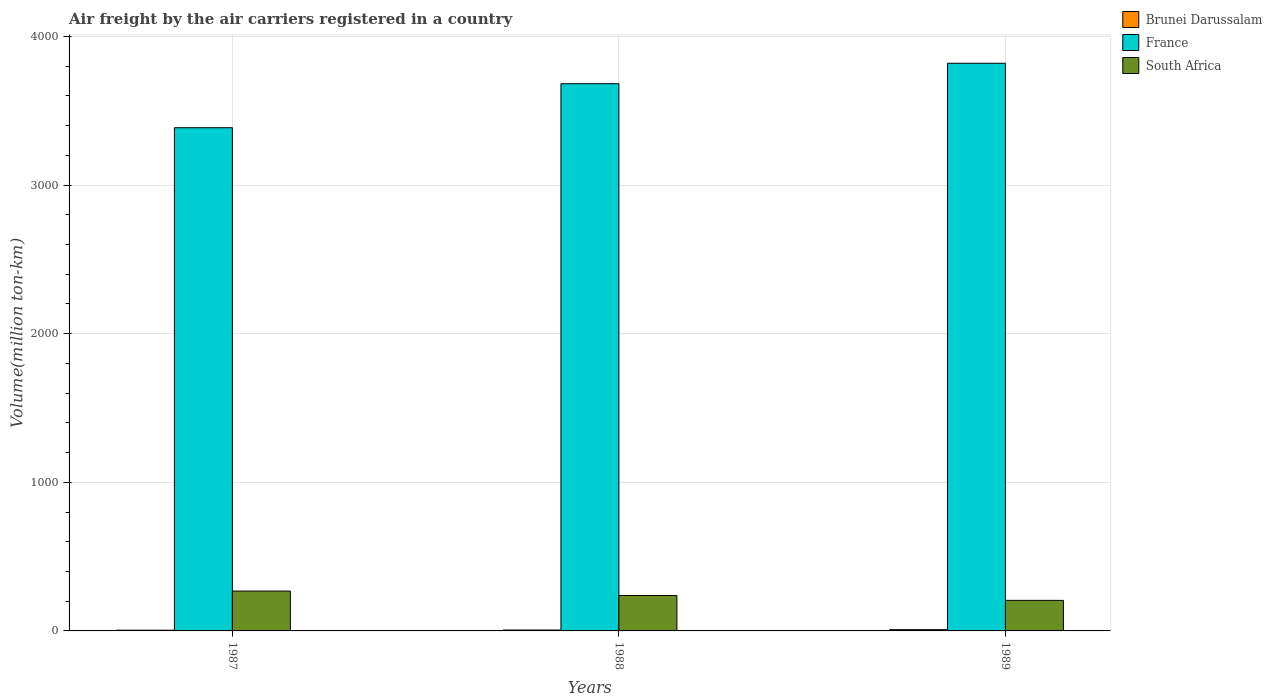How many different coloured bars are there?
Your answer should be compact. 3. Are the number of bars on each tick of the X-axis equal?
Give a very brief answer. Yes. How many bars are there on the 3rd tick from the right?
Offer a very short reply. 3. What is the label of the 2nd group of bars from the left?
Your answer should be very brief. 1988. In how many cases, is the number of bars for a given year not equal to the number of legend labels?
Make the answer very short. 0. What is the volume of the air carriers in Brunei Darussalam in 1988?
Keep it short and to the point. 6. Across all years, what is the maximum volume of the air carriers in France?
Offer a very short reply. 3819.3. Across all years, what is the minimum volume of the air carriers in France?
Offer a terse response. 3385.6. In which year was the volume of the air carriers in France maximum?
Offer a very short reply. 1989. In which year was the volume of the air carriers in France minimum?
Make the answer very short. 1987. What is the total volume of the air carriers in Brunei Darussalam in the graph?
Provide a short and direct response. 19.5. What is the difference between the volume of the air carriers in Brunei Darussalam in 1988 and that in 1989?
Provide a succinct answer. -2.6. What is the difference between the volume of the air carriers in France in 1988 and the volume of the air carriers in South Africa in 1989?
Ensure brevity in your answer.  3476. What is the average volume of the air carriers in France per year?
Provide a succinct answer. 3628.83. In the year 1987, what is the difference between the volume of the air carriers in France and volume of the air carriers in Brunei Darussalam?
Offer a very short reply. 3380.7. In how many years, is the volume of the air carriers in Brunei Darussalam greater than 1200 million ton-km?
Your answer should be compact. 0. What is the ratio of the volume of the air carriers in South Africa in 1987 to that in 1989?
Make the answer very short. 1.3. Is the difference between the volume of the air carriers in France in 1987 and 1988 greater than the difference between the volume of the air carriers in Brunei Darussalam in 1987 and 1988?
Make the answer very short. No. What is the difference between the highest and the second highest volume of the air carriers in Brunei Darussalam?
Provide a succinct answer. 2.6. What is the difference between the highest and the lowest volume of the air carriers in Brunei Darussalam?
Your answer should be very brief. 3.7. In how many years, is the volume of the air carriers in France greater than the average volume of the air carriers in France taken over all years?
Offer a very short reply. 2. What does the 1st bar from the left in 1989 represents?
Provide a short and direct response. Brunei Darussalam. What does the 2nd bar from the right in 1989 represents?
Provide a succinct answer. France. Is it the case that in every year, the sum of the volume of the air carriers in South Africa and volume of the air carriers in France is greater than the volume of the air carriers in Brunei Darussalam?
Your answer should be compact. Yes. What is the difference between two consecutive major ticks on the Y-axis?
Offer a terse response. 1000. Does the graph contain any zero values?
Ensure brevity in your answer.  No. Where does the legend appear in the graph?
Provide a short and direct response. Top right. What is the title of the graph?
Your answer should be very brief. Air freight by the air carriers registered in a country. What is the label or title of the Y-axis?
Your answer should be very brief. Volume(million ton-km). What is the Volume(million ton-km) in Brunei Darussalam in 1987?
Your response must be concise. 4.9. What is the Volume(million ton-km) in France in 1987?
Keep it short and to the point. 3385.6. What is the Volume(million ton-km) of South Africa in 1987?
Your answer should be very brief. 268.1. What is the Volume(million ton-km) of Brunei Darussalam in 1988?
Keep it short and to the point. 6. What is the Volume(million ton-km) in France in 1988?
Offer a terse response. 3681.6. What is the Volume(million ton-km) in South Africa in 1988?
Give a very brief answer. 238.3. What is the Volume(million ton-km) of Brunei Darussalam in 1989?
Provide a succinct answer. 8.6. What is the Volume(million ton-km) of France in 1989?
Offer a very short reply. 3819.3. What is the Volume(million ton-km) in South Africa in 1989?
Your answer should be compact. 205.6. Across all years, what is the maximum Volume(million ton-km) of Brunei Darussalam?
Your response must be concise. 8.6. Across all years, what is the maximum Volume(million ton-km) in France?
Give a very brief answer. 3819.3. Across all years, what is the maximum Volume(million ton-km) in South Africa?
Provide a short and direct response. 268.1. Across all years, what is the minimum Volume(million ton-km) of Brunei Darussalam?
Offer a terse response. 4.9. Across all years, what is the minimum Volume(million ton-km) of France?
Your answer should be very brief. 3385.6. Across all years, what is the minimum Volume(million ton-km) of South Africa?
Offer a terse response. 205.6. What is the total Volume(million ton-km) of France in the graph?
Provide a short and direct response. 1.09e+04. What is the total Volume(million ton-km) in South Africa in the graph?
Provide a short and direct response. 712. What is the difference between the Volume(million ton-km) of France in 1987 and that in 1988?
Your answer should be compact. -296. What is the difference between the Volume(million ton-km) of South Africa in 1987 and that in 1988?
Keep it short and to the point. 29.8. What is the difference between the Volume(million ton-km) in Brunei Darussalam in 1987 and that in 1989?
Your response must be concise. -3.7. What is the difference between the Volume(million ton-km) of France in 1987 and that in 1989?
Provide a short and direct response. -433.7. What is the difference between the Volume(million ton-km) of South Africa in 1987 and that in 1989?
Ensure brevity in your answer.  62.5. What is the difference between the Volume(million ton-km) in France in 1988 and that in 1989?
Offer a terse response. -137.7. What is the difference between the Volume(million ton-km) in South Africa in 1988 and that in 1989?
Keep it short and to the point. 32.7. What is the difference between the Volume(million ton-km) in Brunei Darussalam in 1987 and the Volume(million ton-km) in France in 1988?
Make the answer very short. -3676.7. What is the difference between the Volume(million ton-km) of Brunei Darussalam in 1987 and the Volume(million ton-km) of South Africa in 1988?
Provide a succinct answer. -233.4. What is the difference between the Volume(million ton-km) of France in 1987 and the Volume(million ton-km) of South Africa in 1988?
Offer a very short reply. 3147.3. What is the difference between the Volume(million ton-km) of Brunei Darussalam in 1987 and the Volume(million ton-km) of France in 1989?
Provide a short and direct response. -3814.4. What is the difference between the Volume(million ton-km) of Brunei Darussalam in 1987 and the Volume(million ton-km) of South Africa in 1989?
Offer a very short reply. -200.7. What is the difference between the Volume(million ton-km) in France in 1987 and the Volume(million ton-km) in South Africa in 1989?
Ensure brevity in your answer.  3180. What is the difference between the Volume(million ton-km) in Brunei Darussalam in 1988 and the Volume(million ton-km) in France in 1989?
Give a very brief answer. -3813.3. What is the difference between the Volume(million ton-km) of Brunei Darussalam in 1988 and the Volume(million ton-km) of South Africa in 1989?
Provide a succinct answer. -199.6. What is the difference between the Volume(million ton-km) in France in 1988 and the Volume(million ton-km) in South Africa in 1989?
Provide a succinct answer. 3476. What is the average Volume(million ton-km) of France per year?
Your answer should be compact. 3628.83. What is the average Volume(million ton-km) of South Africa per year?
Offer a very short reply. 237.33. In the year 1987, what is the difference between the Volume(million ton-km) of Brunei Darussalam and Volume(million ton-km) of France?
Your answer should be compact. -3380.7. In the year 1987, what is the difference between the Volume(million ton-km) of Brunei Darussalam and Volume(million ton-km) of South Africa?
Keep it short and to the point. -263.2. In the year 1987, what is the difference between the Volume(million ton-km) in France and Volume(million ton-km) in South Africa?
Ensure brevity in your answer.  3117.5. In the year 1988, what is the difference between the Volume(million ton-km) in Brunei Darussalam and Volume(million ton-km) in France?
Your answer should be compact. -3675.6. In the year 1988, what is the difference between the Volume(million ton-km) in Brunei Darussalam and Volume(million ton-km) in South Africa?
Make the answer very short. -232.3. In the year 1988, what is the difference between the Volume(million ton-km) in France and Volume(million ton-km) in South Africa?
Offer a terse response. 3443.3. In the year 1989, what is the difference between the Volume(million ton-km) in Brunei Darussalam and Volume(million ton-km) in France?
Make the answer very short. -3810.7. In the year 1989, what is the difference between the Volume(million ton-km) of Brunei Darussalam and Volume(million ton-km) of South Africa?
Give a very brief answer. -197. In the year 1989, what is the difference between the Volume(million ton-km) in France and Volume(million ton-km) in South Africa?
Offer a very short reply. 3613.7. What is the ratio of the Volume(million ton-km) of Brunei Darussalam in 1987 to that in 1988?
Provide a short and direct response. 0.82. What is the ratio of the Volume(million ton-km) in France in 1987 to that in 1988?
Offer a terse response. 0.92. What is the ratio of the Volume(million ton-km) of South Africa in 1987 to that in 1988?
Give a very brief answer. 1.13. What is the ratio of the Volume(million ton-km) of Brunei Darussalam in 1987 to that in 1989?
Your answer should be very brief. 0.57. What is the ratio of the Volume(million ton-km) in France in 1987 to that in 1989?
Provide a succinct answer. 0.89. What is the ratio of the Volume(million ton-km) of South Africa in 1987 to that in 1989?
Provide a succinct answer. 1.3. What is the ratio of the Volume(million ton-km) of Brunei Darussalam in 1988 to that in 1989?
Give a very brief answer. 0.7. What is the ratio of the Volume(million ton-km) of France in 1988 to that in 1989?
Offer a terse response. 0.96. What is the ratio of the Volume(million ton-km) in South Africa in 1988 to that in 1989?
Ensure brevity in your answer.  1.16. What is the difference between the highest and the second highest Volume(million ton-km) in Brunei Darussalam?
Offer a terse response. 2.6. What is the difference between the highest and the second highest Volume(million ton-km) in France?
Ensure brevity in your answer.  137.7. What is the difference between the highest and the second highest Volume(million ton-km) of South Africa?
Make the answer very short. 29.8. What is the difference between the highest and the lowest Volume(million ton-km) of France?
Your response must be concise. 433.7. What is the difference between the highest and the lowest Volume(million ton-km) in South Africa?
Offer a very short reply. 62.5. 